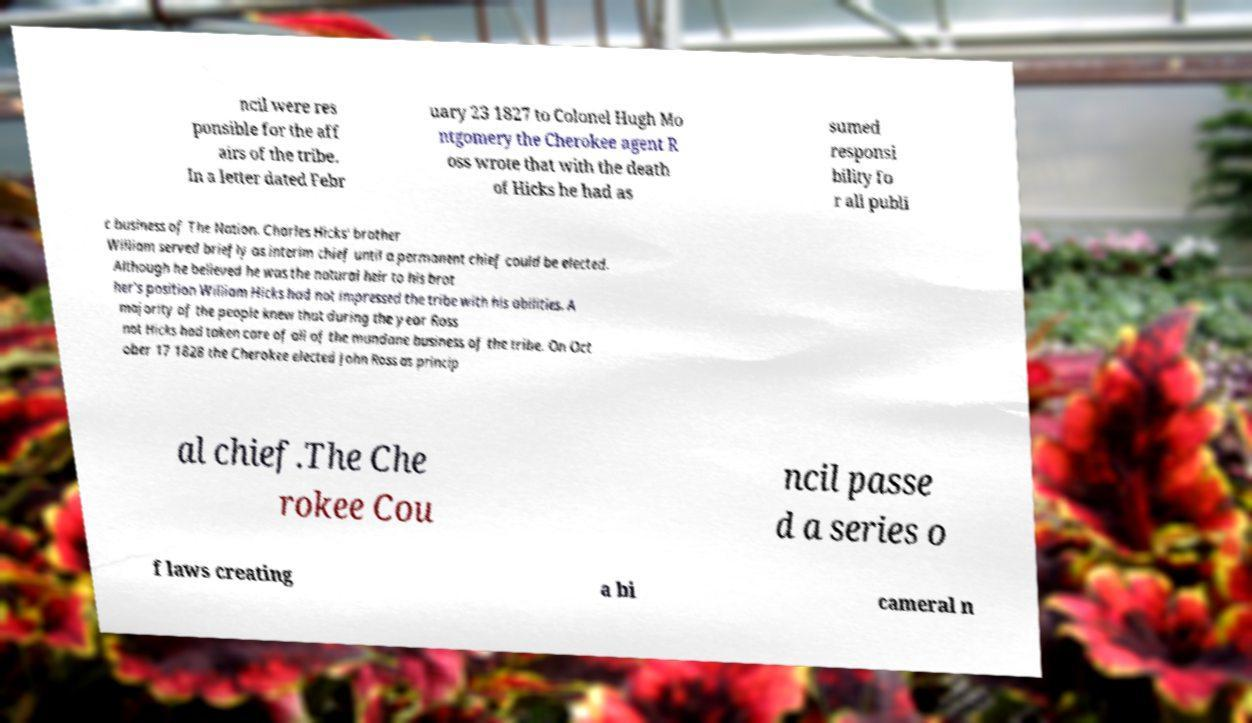Please read and relay the text visible in this image. What does it say? ncil were res ponsible for the aff airs of the tribe. In a letter dated Febr uary 23 1827 to Colonel Hugh Mo ntgomery the Cherokee agent R oss wrote that with the death of Hicks he had as sumed responsi bility fo r all publi c business of The Nation. Charles Hicks' brother William served briefly as interim chief until a permanent chief could be elected. Although he believed he was the natural heir to his brot her's position William Hicks had not impressed the tribe with his abilities. A majority of the people knew that during the year Ross not Hicks had taken care of all of the mundane business of the tribe. On Oct ober 17 1828 the Cherokee elected John Ross as princip al chief.The Che rokee Cou ncil passe d a series o f laws creating a bi cameral n 